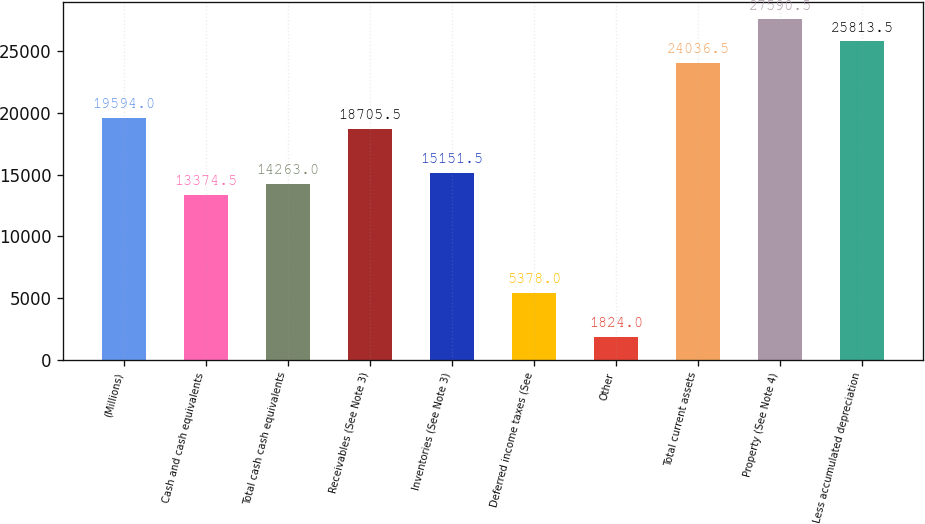<chart> <loc_0><loc_0><loc_500><loc_500><bar_chart><fcel>(Millions)<fcel>Cash and cash equivalents<fcel>Total cash cash equivalents<fcel>Receivables (See Note 3)<fcel>Inventories (See Note 3)<fcel>Deferred income taxes (See<fcel>Other<fcel>Total current assets<fcel>Property (See Note 4)<fcel>Less accumulated depreciation<nl><fcel>19594<fcel>13374.5<fcel>14263<fcel>18705.5<fcel>15151.5<fcel>5378<fcel>1824<fcel>24036.5<fcel>27590.5<fcel>25813.5<nl></chart> 